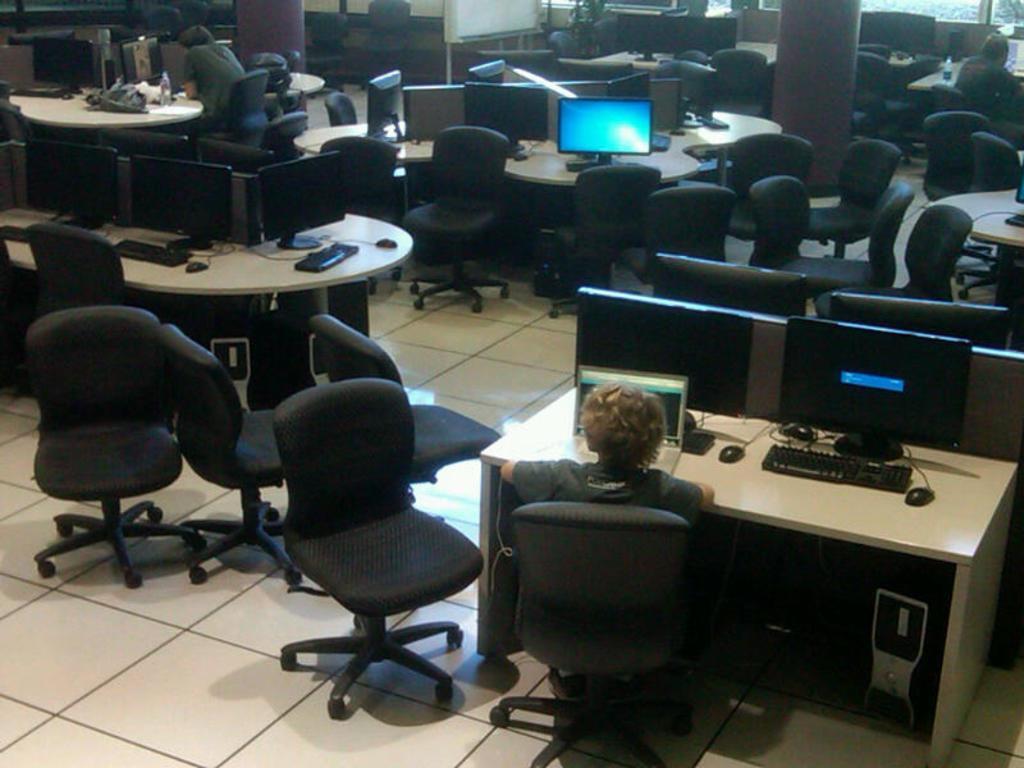Please provide a concise description of this image. On the top left, a person is sitting on the chair in front of the table. At the bottom, a woman is sitting on the chair in front of the table on which laptop, keyboard, systems are kept. On the top right, a person is sitting on the chair in front of the table. On both side there are chair and tables and systems visible. The pillars are brown in color. It looks as if the image is taken inside a office. 